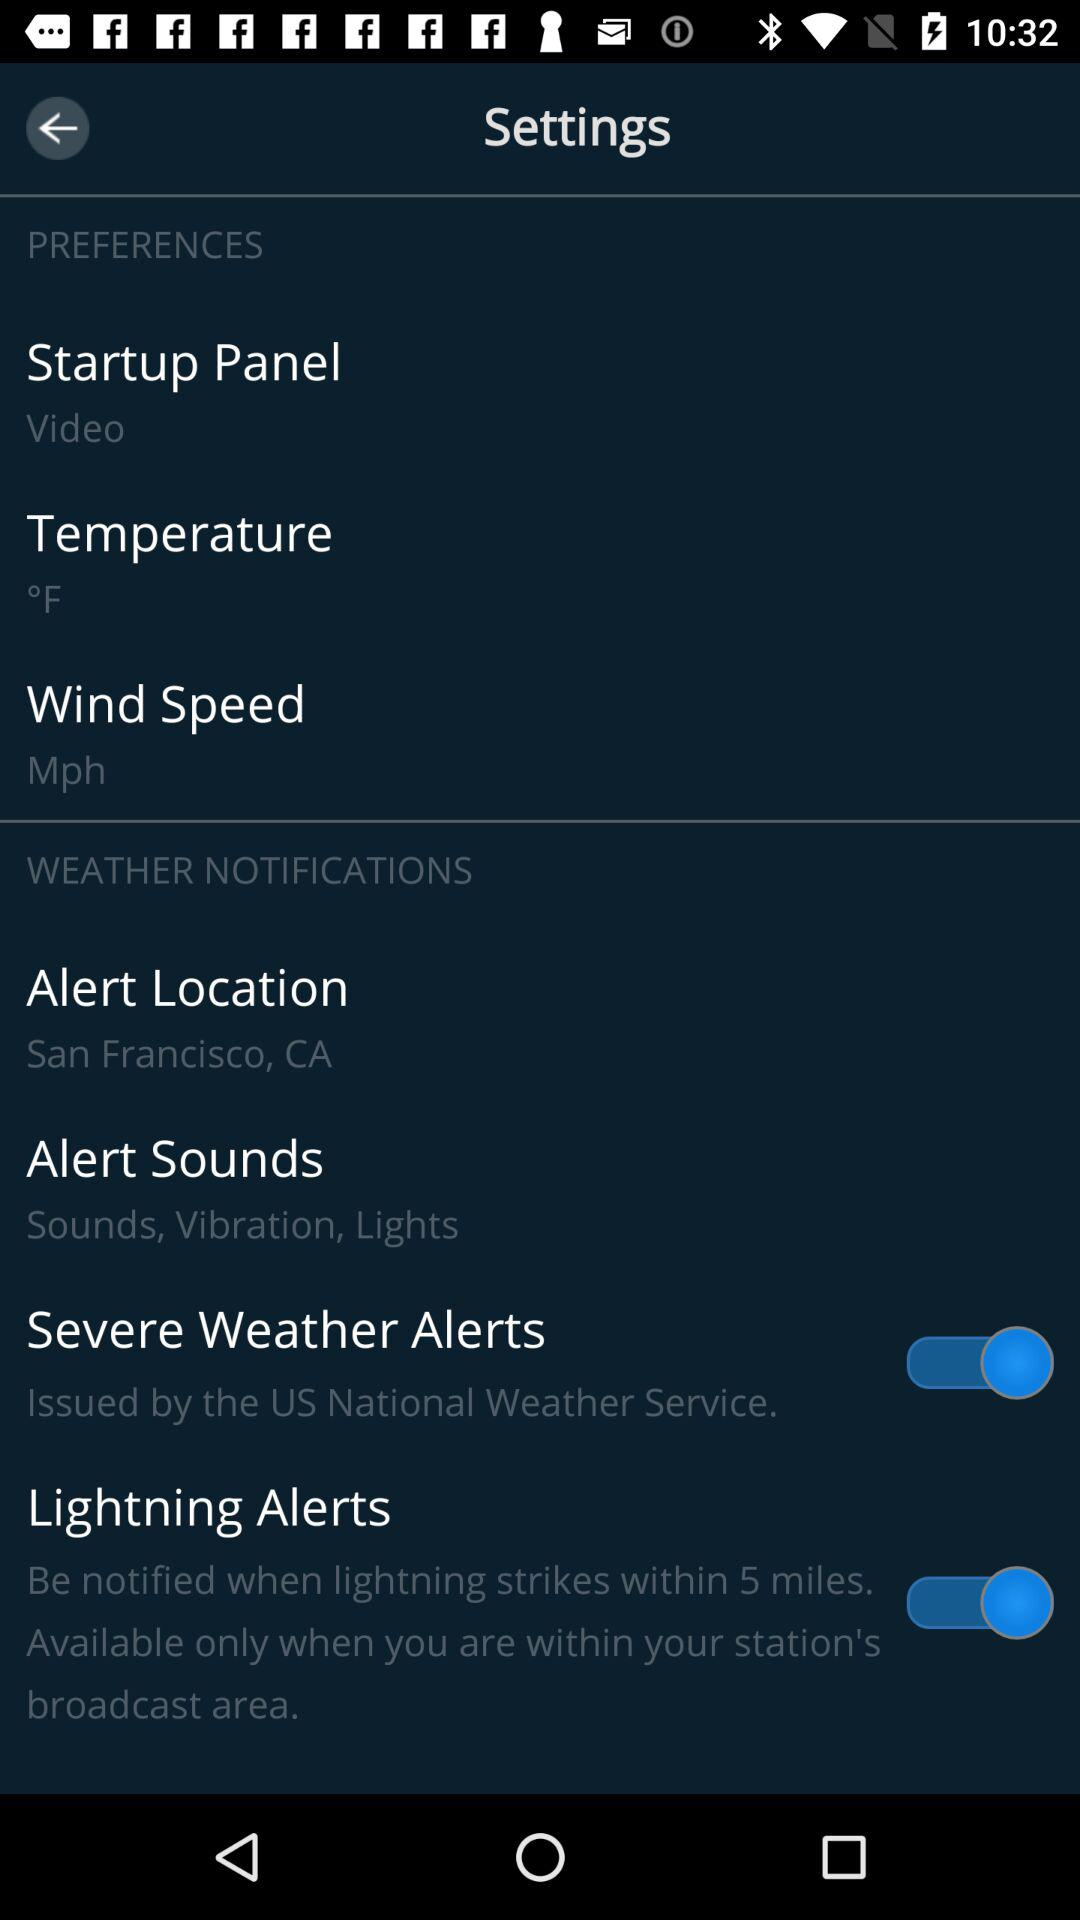What is the status of "Severe Weather Alerts"? The status is "on". 